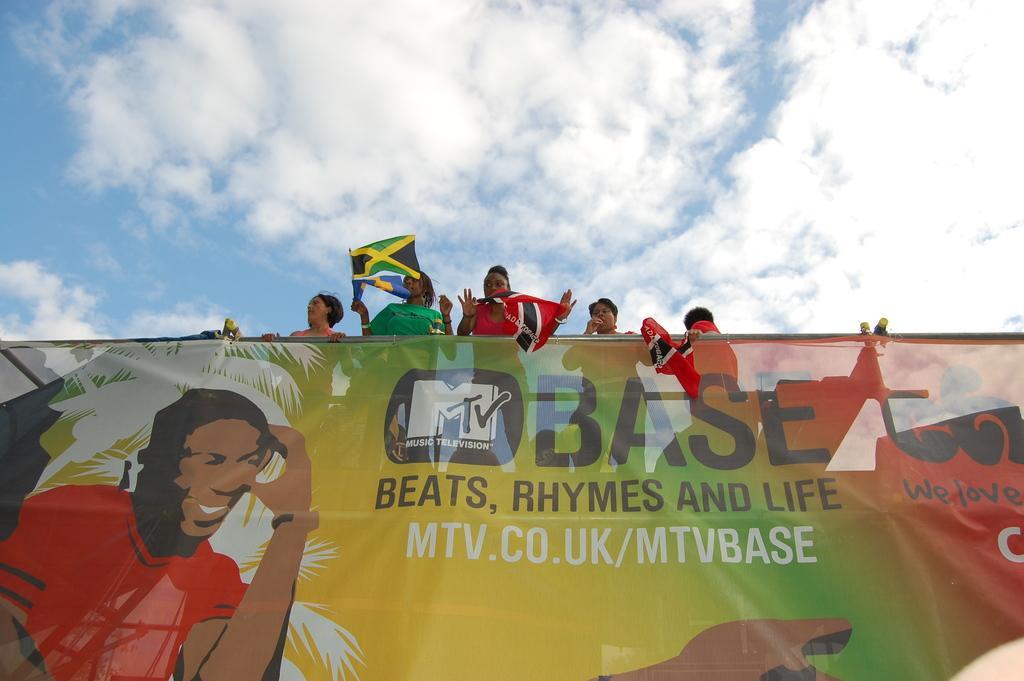Describe this image in one or two sentences. At the bottom of this image, there is a banner having paintings of a person, trees and texts. Above this banner, there are persons. Three of them are holding flags. In the background, there are clouds in the blue sky. 